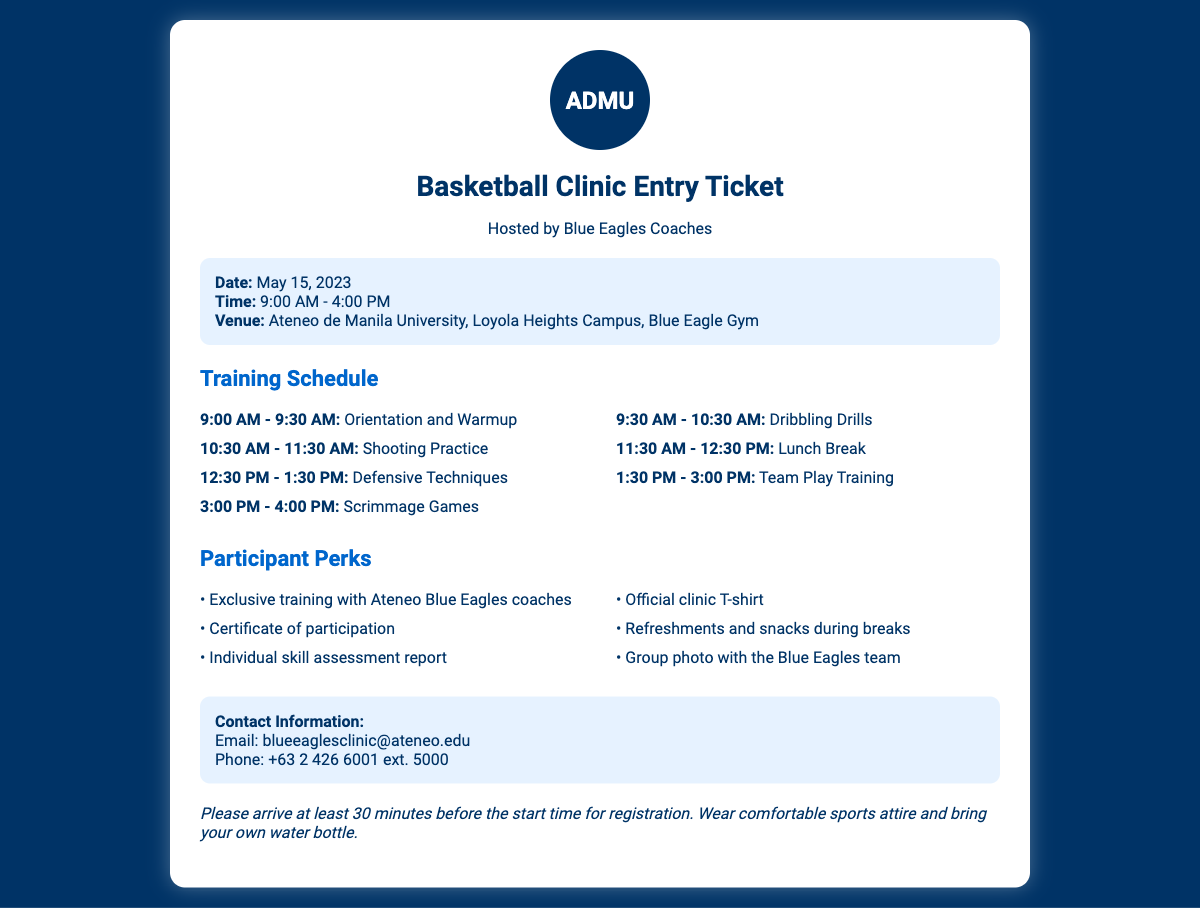What is the date of the basketball clinic? The date is specified in the document as May 15, 2023.
Answer: May 15, 2023 What time does the basketball clinic start? The start time is stated in the document as 9:00 AM.
Answer: 9:00 AM Who is hosting the clinic? The document indicates that the clinic is hosted by the Blue Eagles Coaches.
Answer: Blue Eagles Coaches What venue will the basketball clinic be held at? The venue is mentioned as Ateneo de Manila University, Loyola Heights Campus, Blue Eagle Gym.
Answer: Ateneo de Manila University, Loyola Heights Campus, Blue Eagle Gym How long is the lunch break scheduled for? The lunch break duration is provided in the schedule, which is from 11:30 AM to 12:30 PM, indicating a one-hour break.
Answer: 1 hour What is one of the participant perks mentioned in the document? The document lists several perks, one of which is an official clinic T-shirt.
Answer: Official clinic T-shirt How many participants are expected to have a group photo with the Blue Eagles team? The document states that every participant will receive the perk of a group photo with the Blue Eagles team.
Answer: Every participant When should participants arrive for registration? The note advises participants to arrive at least 30 minutes before the start time for registration.
Answer: 30 minutes before What is one of the skills participants will work on during the clinic? The training schedule includes items such as shooting practice, indicating that shooting skills will be developed.
Answer: Shooting practice 